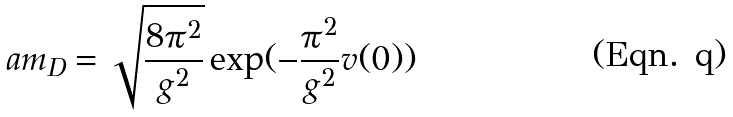Convert formula to latex. <formula><loc_0><loc_0><loc_500><loc_500>a m _ { D } = \sqrt { \frac { 8 \pi ^ { 2 } } { g ^ { 2 } } } \exp ( - \frac { \pi ^ { 2 } } { g ^ { 2 } } v ( 0 ) )</formula> 